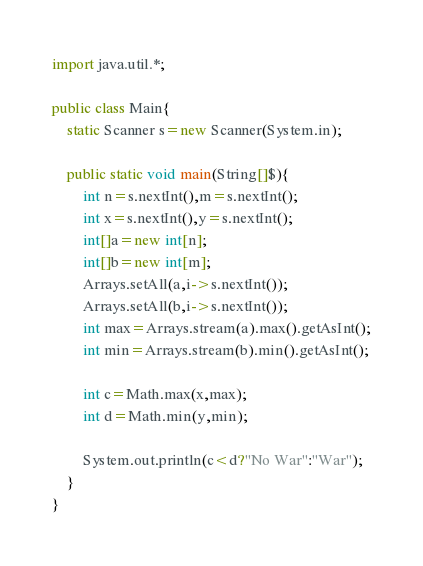<code> <loc_0><loc_0><loc_500><loc_500><_Java_>import java.util.*;

public class Main{
	static Scanner s=new Scanner(System.in);

	public static void main(String[]$){
		int n=s.nextInt(),m=s.nextInt();
		int x=s.nextInt(),y=s.nextInt();
		int[]a=new int[n];
		int[]b=new int[m];
		Arrays.setAll(a,i->s.nextInt());
		Arrays.setAll(b,i->s.nextInt());
		int max=Arrays.stream(a).max().getAsInt();
		int min=Arrays.stream(b).min().getAsInt();
		
		int c=Math.max(x,max);
		int d=Math.min(y,min);
		
		System.out.println(c<d?"No War":"War");
	}
}</code> 